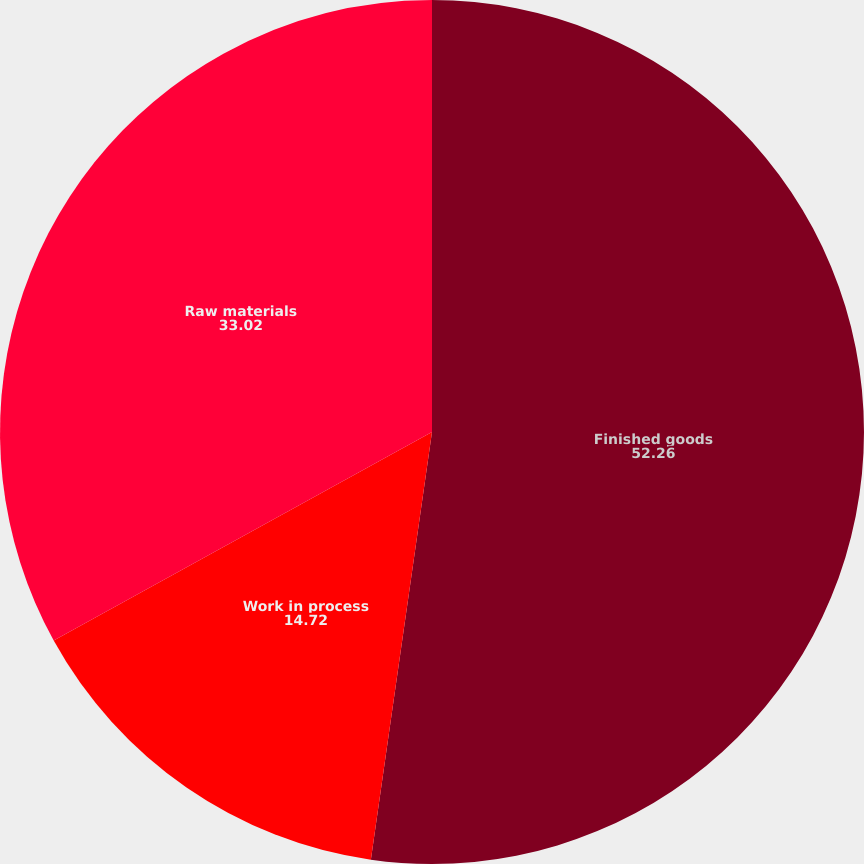<chart> <loc_0><loc_0><loc_500><loc_500><pie_chart><fcel>Finished goods<fcel>Work in process<fcel>Raw materials<nl><fcel>52.26%<fcel>14.72%<fcel>33.02%<nl></chart> 